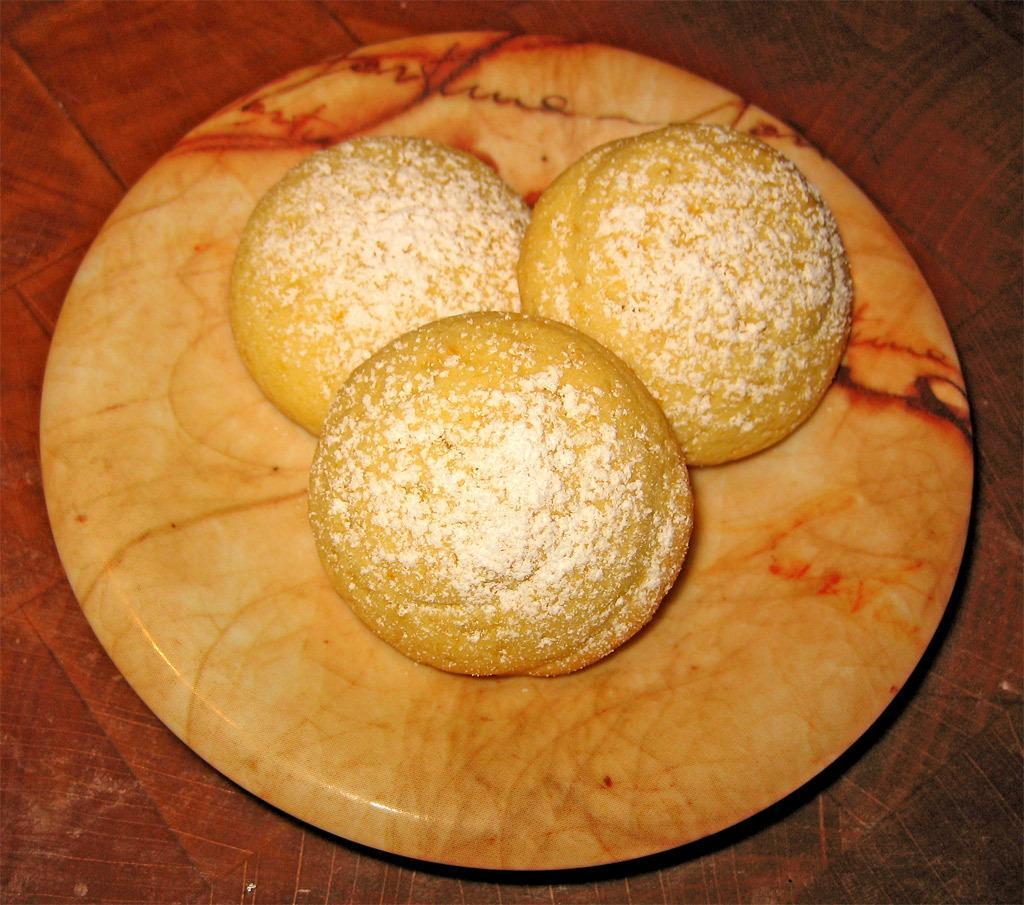Describe this image in one or two sentences. In this image there are three buns placed in a plate on the top of the table. 